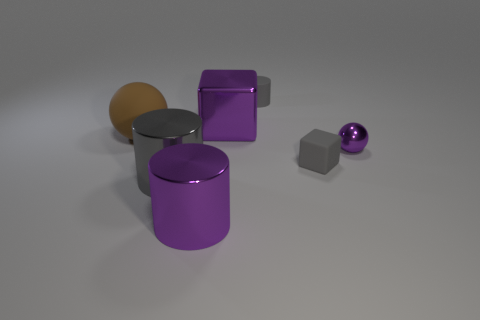How would you interpret the mood or theme conveyed by the scene? The scene has a minimalist and contemporary feel, characterized by a neutral background and well-defined geometric shapes. The interplay of matte and reflective surfaces, along with the subdued color palette predominantly featuring purple, evokes a sense of calmness and order. The solitary positions of the objects might suggest themes of isolation or individuality. 